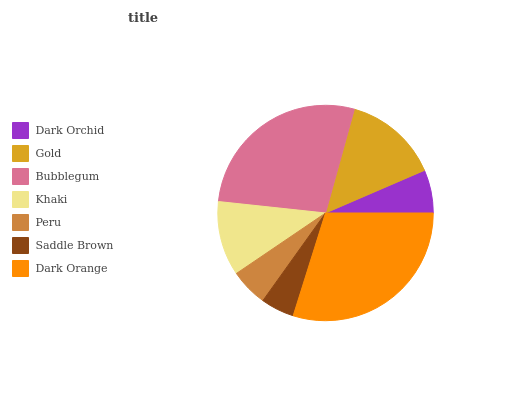Is Saddle Brown the minimum?
Answer yes or no. Yes. Is Dark Orange the maximum?
Answer yes or no. Yes. Is Gold the minimum?
Answer yes or no. No. Is Gold the maximum?
Answer yes or no. No. Is Gold greater than Dark Orchid?
Answer yes or no. Yes. Is Dark Orchid less than Gold?
Answer yes or no. Yes. Is Dark Orchid greater than Gold?
Answer yes or no. No. Is Gold less than Dark Orchid?
Answer yes or no. No. Is Khaki the high median?
Answer yes or no. Yes. Is Khaki the low median?
Answer yes or no. Yes. Is Dark Orchid the high median?
Answer yes or no. No. Is Dark Orchid the low median?
Answer yes or no. No. 